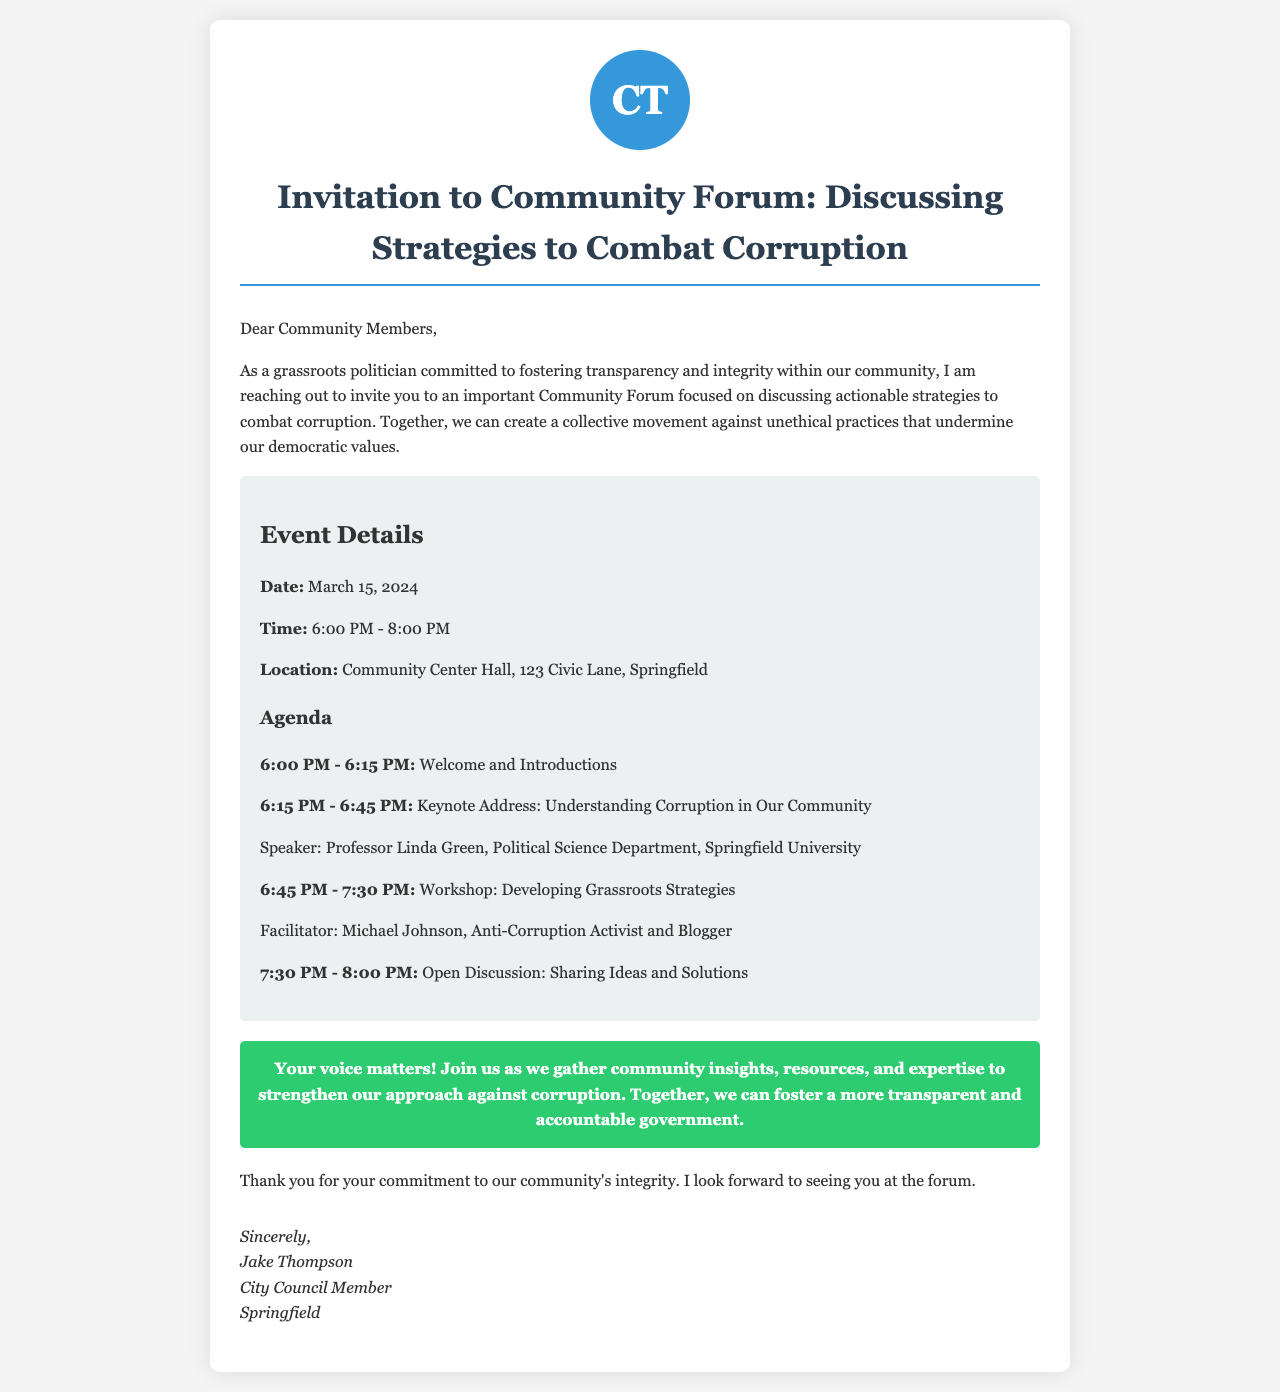What is the date of the event? The date of the event is specified within the document, and it states March 15, 2024.
Answer: March 15, 2024 Who is the keynote speaker? The document mentions that Professor Linda Green will be speaking on the topic of corruption in the community.
Answer: Professor Linda Green What time does the forum start? The document specifies the time of the event's commencement as 6:00 PM.
Answer: 6:00 PM Where is the location of the forum? The venue for the forum is mentioned in the document as the Community Center Hall, 123 Civic Lane, Springfield.
Answer: Community Center Hall, 123 Civic Lane, Springfield What is the main focus of the Community Forum? It is stated in the document that the focus of the forum is on discussing actionable strategies to combat corruption.
Answer: Strategies to combat corruption How long is the workshop session? The document details that the workshop session is from 6:45 PM to 7:30 PM, totaling 45 minutes.
Answer: 45 minutes Who is facilitating the workshop? The facilitator for the workshop is identified in the document as Michael Johnson, an anti-corruption activist and blogger.
Answer: Michael Johnson What is the last agenda item of the forum? The document indicates that the last agenda item is an Open Discussion for sharing ideas and solutions.
Answer: Open Discussion: Sharing Ideas and Solutions 